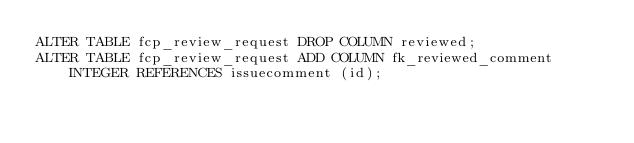<code> <loc_0><loc_0><loc_500><loc_500><_SQL_>ALTER TABLE fcp_review_request DROP COLUMN reviewed;
ALTER TABLE fcp_review_request ADD COLUMN fk_reviewed_comment INTEGER REFERENCES issuecomment (id);
</code> 